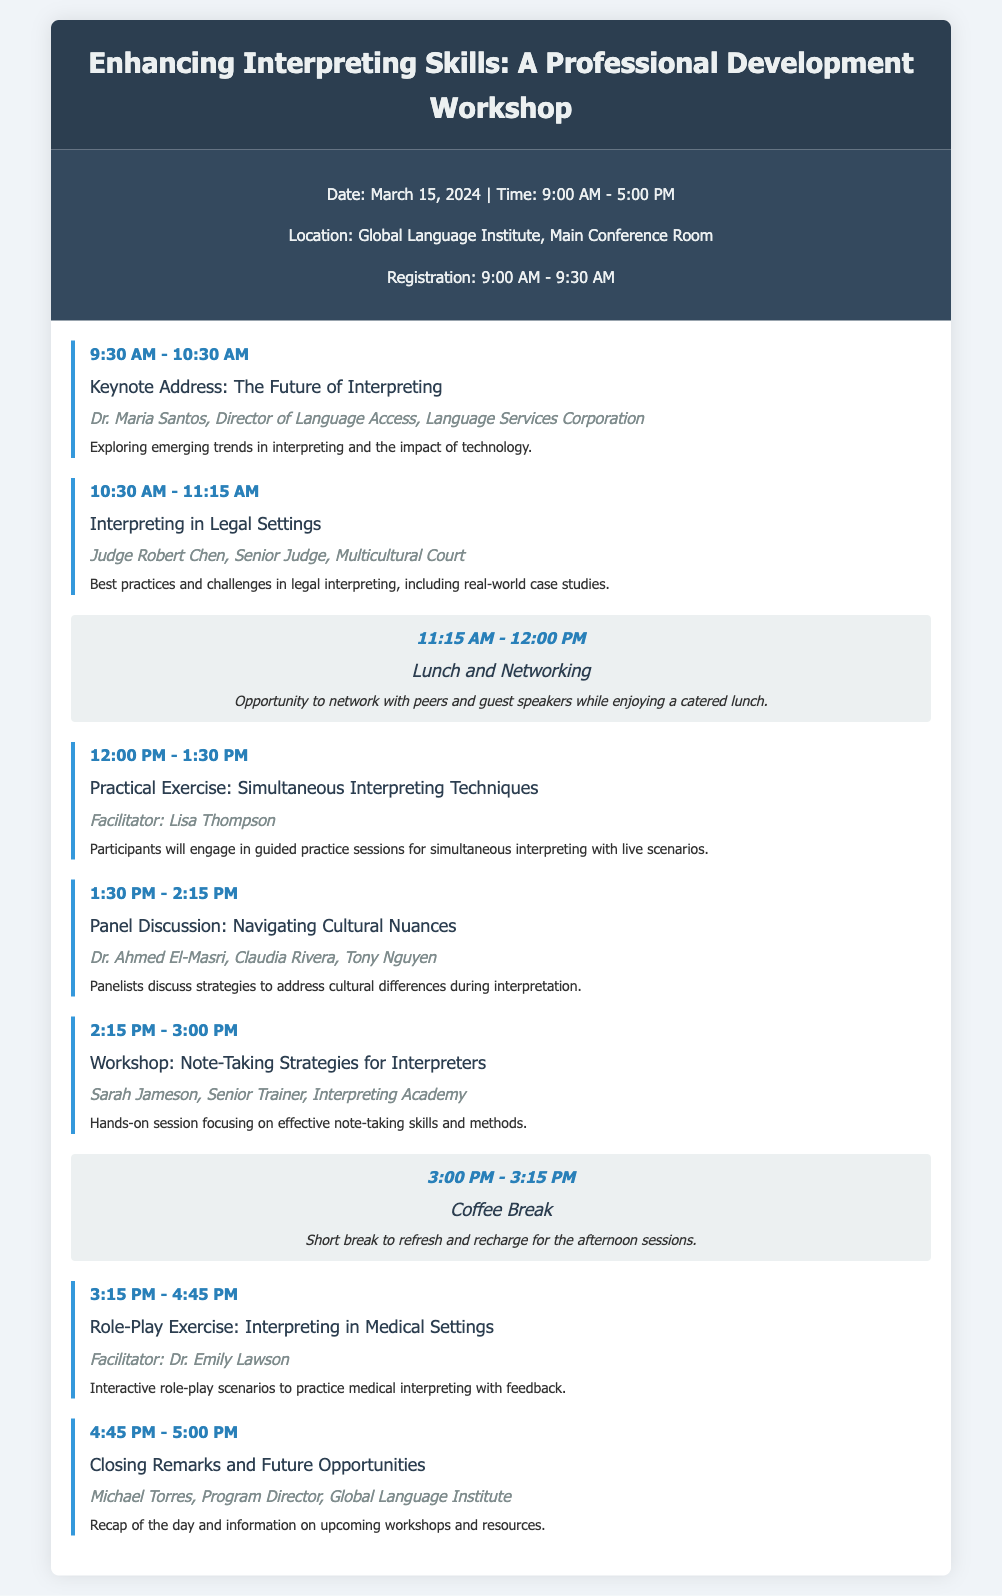What is the date of the workshop? The date is mentioned in the workshop info section.
Answer: March 15, 2024 Who is the keynote speaker? The keynote speaker is listed under the first session in the agenda.
Answer: Dr. Maria Santos What time does registration start? The registration time is specifically stated in the workshop info section.
Answer: 9:00 AM What is the duration of the practical exercise on simultaneous interpreting techniques? The duration is indicated in the session details for that specific section.
Answer: 1 hour 30 minutes Which session features a panel discussion? The panel discussion is highlighted in the agenda as a separate session.
Answer: Panel Discussion: Navigating Cultural Nuances What is the topic covered in the closing remarks? The topic of the closing remarks can be found in the last session description.
Answer: Future Opportunities How long is the coffee break? The duration of the coffee break is mentioned directly before its title in the agenda.
Answer: 15 minutes Who is the facilitator for the role-play exercise? The facilitator's name is provided in the session details of the role-play exercise section.
Answer: Dr. Emily Lawson What time does the workshop start? The starting time is noted in the workshop info section.
Answer: 9:30 AM 